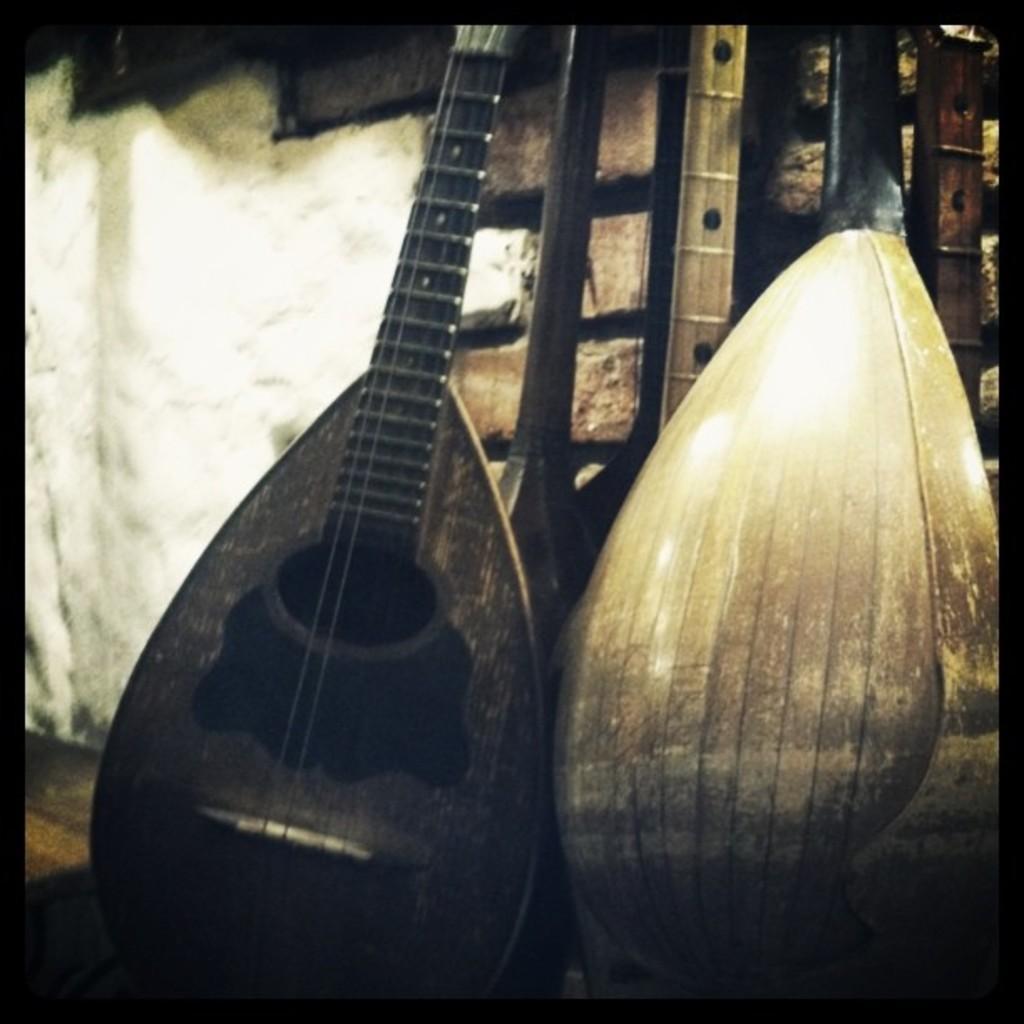Describe this image in one or two sentences. In this picture we can see the guitars which is kept near to the brick wall. In the bottom left we can see wooden floor. 